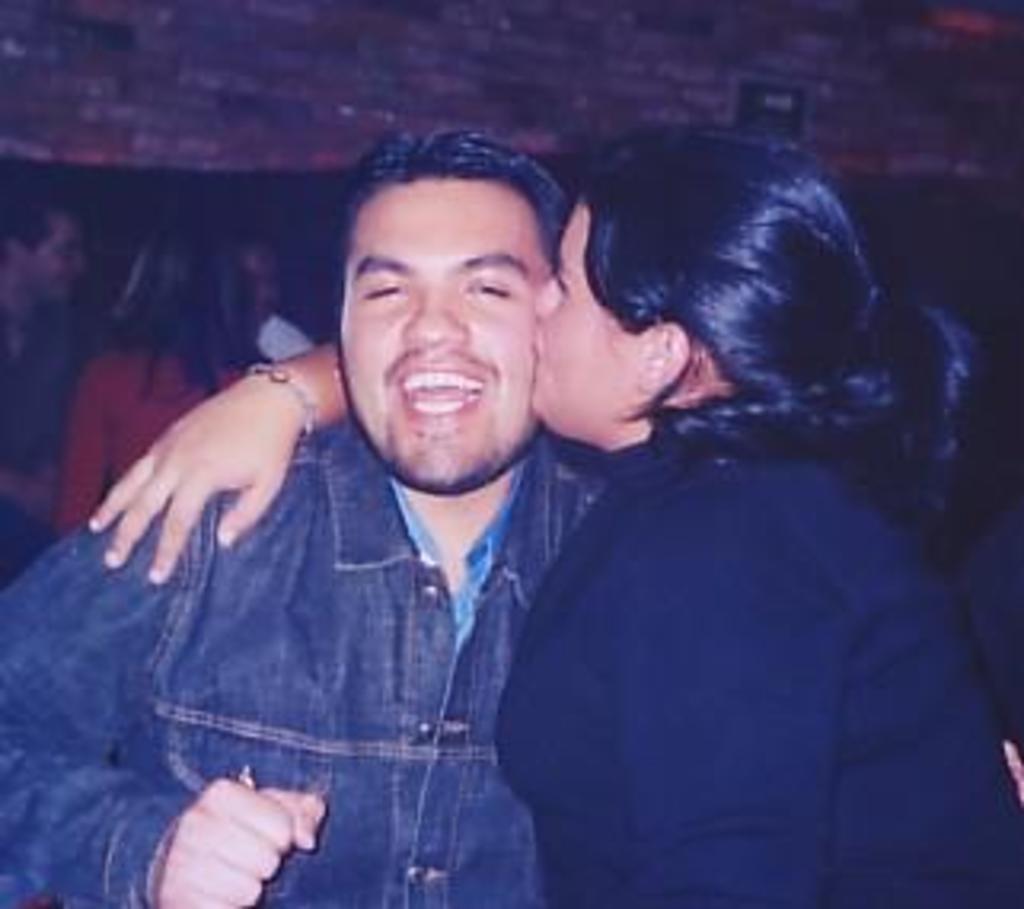Could you give a brief overview of what you see in this image? In the picture I can see a woman wearing black dress is kissing on the cheeks of a man in front of him and there are few other persons in the background. 